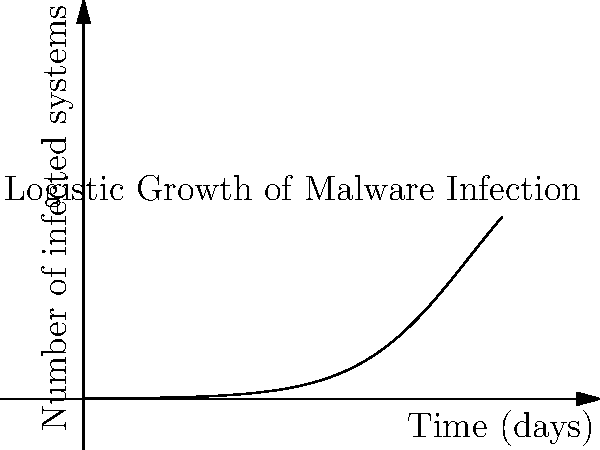A new malware has been detected in a network of 1000 systems. The spread of the infection follows a logistic growth curve described by the function $N(t) = \frac{1000}{1 + 999e^{-0.5t}}$, where $N(t)$ is the number of infected systems and $t$ is the time in days. How many days will it take for half of the systems to become infected? To find when half of the systems are infected, we need to solve the equation:

1. Set $N(t) = 500$ (half of 1000 systems):

   $500 = \frac{1000}{1 + 999e^{-0.5t}}$

2. Multiply both sides by the denominator:

   $500(1 + 999e^{-0.5t}) = 1000$

3. Distribute on the left side:

   $500 + 499500e^{-0.5t} = 1000$

4. Subtract 500 from both sides:

   $499500e^{-0.5t} = 500$

5. Divide both sides by 499500:

   $e^{-0.5t} = \frac{1}{999}$

6. Take the natural log of both sides:

   $-0.5t = \ln(\frac{1}{999})$

7. Multiply both sides by -2:

   $t = -2\ln(\frac{1}{999})$

8. Simplify:

   $t = 2\ln(999)$

9. Calculate the result:

   $t \approx 13.81$ days

Therefore, it will take approximately 13.81 days for half of the systems to become infected.
Answer: $2\ln(999) \approx 13.81$ days 